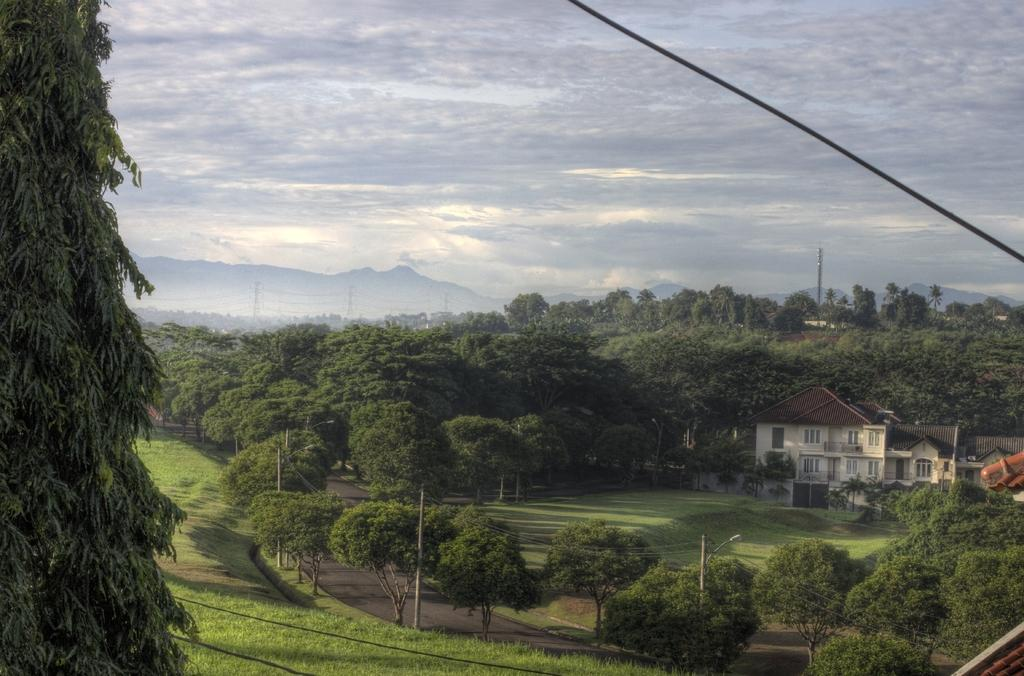What type of vegetation can be seen in the image? There are trees in the image. What type of structure is present in the image? There is a house in the image. What geographical feature is visible in the background of the image? There is a mountain in the background of the image. What is visible in the sky in the image? The sky is visible in the background of the image. Where is the hydrant located in the image? There is no hydrant present in the image. What type of love is depicted in the image? There is no depiction of love in the image; it features trees, a house, a mountain, and the sky. 